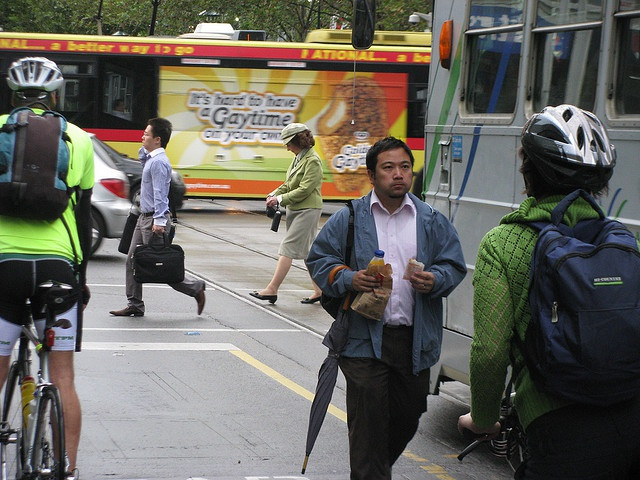Describe the objects in this image and their specific colors. I can see people in black, gray, and darkgreen tones, bus in black, tan, darkgray, and lightgray tones, bus in black and gray tones, people in black, gray, and darkblue tones, and people in black, gray, lightgreen, and darkgray tones in this image. 